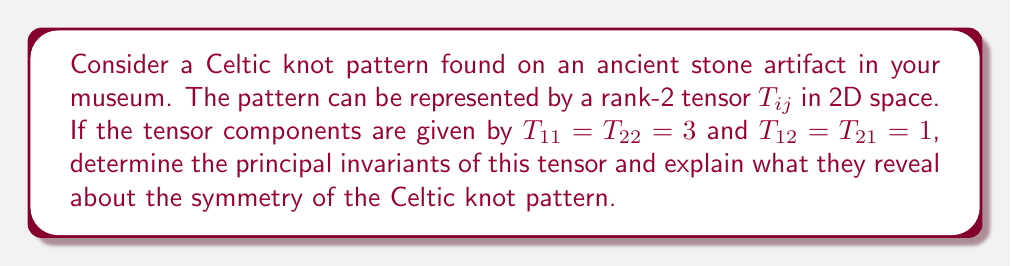Teach me how to tackle this problem. Let's approach this step-by-step:

1) For a 2D tensor, there are two principal invariants:
   $I_1 = tr(T)$ (the trace)
   $I_2 = det(T)$ (the determinant)

2) The tensor is given as:
   $$T = \begin{pmatrix}
   3 & 1 \\
   1 & 3
   \end{pmatrix}$$

3) Calculate $I_1$:
   $I_1 = tr(T) = T_{11} + T_{22} = 3 + 3 = 6$

4) Calculate $I_2$:
   $I_2 = det(T) = T_{11}T_{22} - T_{12}T_{21} = 3 \cdot 3 - 1 \cdot 1 = 8$

5) Interpretation:
   - $I_1 = 6$ indicates the sum of the principal strains or stretches in the pattern.
   - $I_2 = 8$ represents the area change under the transformation.

6) Symmetry analysis:
   - The tensor is symmetric ($T_{12} = T_{21}$), indicating the pattern has reflection symmetry.
   - The diagonal elements are equal ($T_{11} = T_{22}$), suggesting rotational symmetry.
   - These properties combined imply the Celtic knot pattern likely has both reflectional and 90-degree rotational symmetry.

7) In tensor notation, this symmetry can be expressed as:
   $T_{ij} = T_{ji}$ (reflection symmetry)
   $T_{11} = T_{22}$ (rotational symmetry)

This analysis reveals that the Celtic knot pattern on your artifact exhibits a high degree of geometric balance and regularity, typical of many Celtic designs.
Answer: $I_1 = 6$, $I_2 = 8$; Pattern has reflection and 90-degree rotational symmetry. 